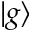<formula> <loc_0><loc_0><loc_500><loc_500>| g \rangle</formula> 